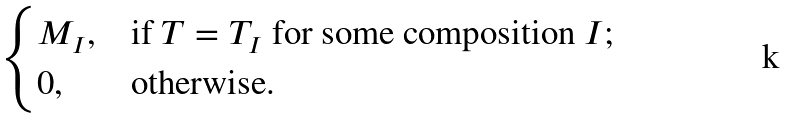Convert formula to latex. <formula><loc_0><loc_0><loc_500><loc_500>\begin{cases} M _ { I } , & \text {if $T=T_{I}$ for some composition $I$;} \\ 0 , & \text {otherwise.} \end{cases}</formula> 